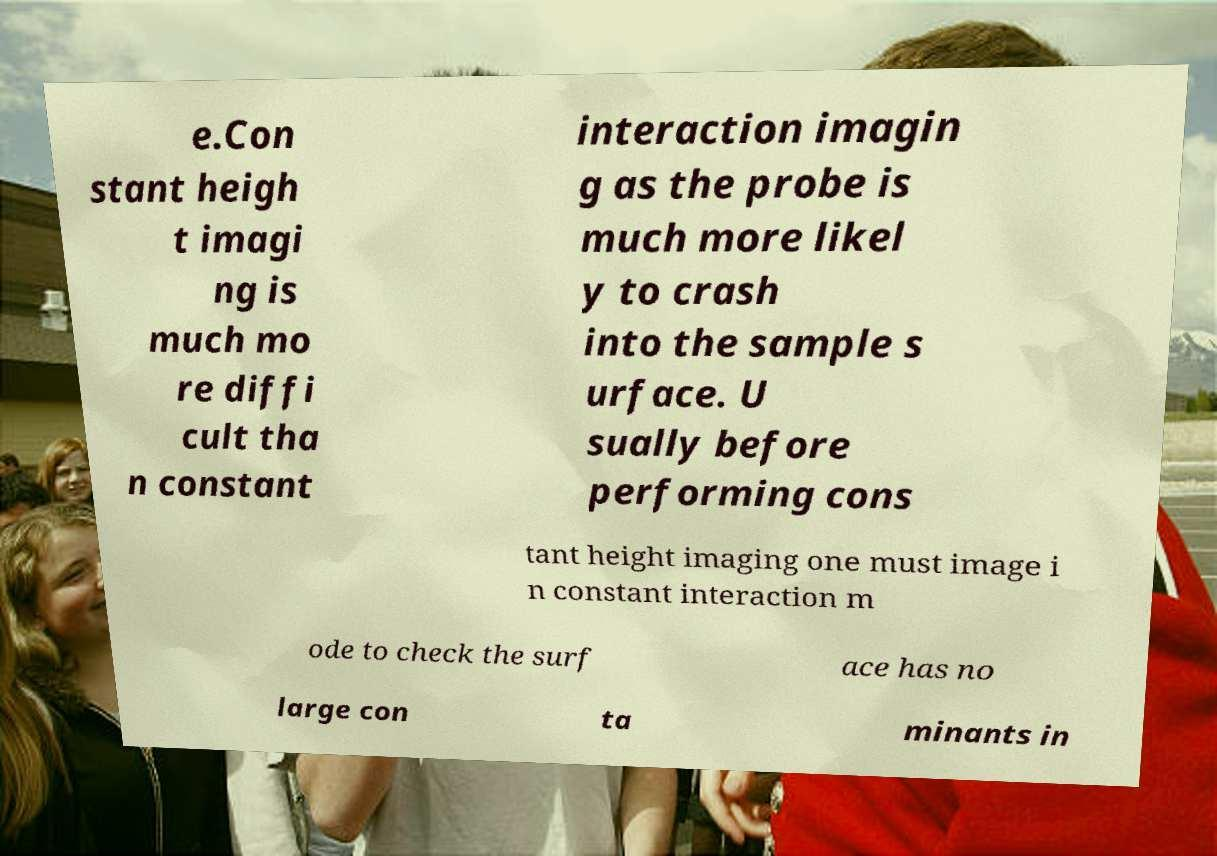Could you extract and type out the text from this image? e.Con stant heigh t imagi ng is much mo re diffi cult tha n constant interaction imagin g as the probe is much more likel y to crash into the sample s urface. U sually before performing cons tant height imaging one must image i n constant interaction m ode to check the surf ace has no large con ta minants in 